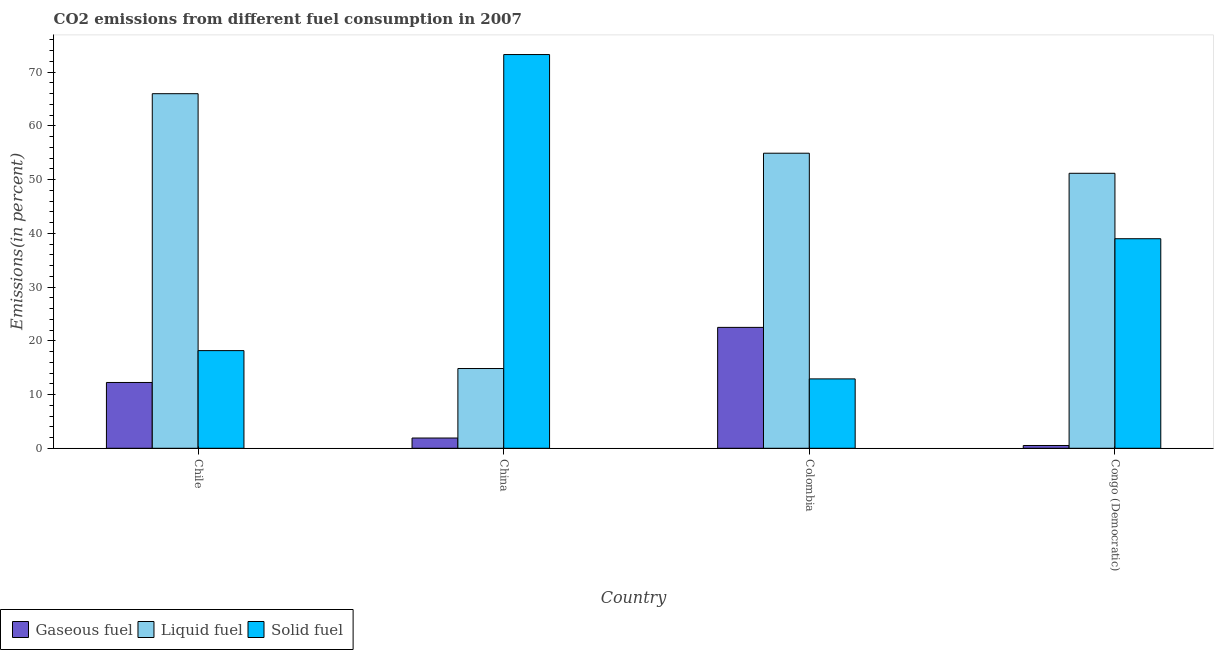How many different coloured bars are there?
Provide a short and direct response. 3. Are the number of bars per tick equal to the number of legend labels?
Your answer should be compact. Yes. Are the number of bars on each tick of the X-axis equal?
Make the answer very short. Yes. What is the percentage of solid fuel emission in Congo (Democratic)?
Make the answer very short. 38.99. Across all countries, what is the maximum percentage of liquid fuel emission?
Offer a very short reply. 65.98. Across all countries, what is the minimum percentage of solid fuel emission?
Your answer should be very brief. 12.91. In which country was the percentage of gaseous fuel emission maximum?
Keep it short and to the point. Colombia. In which country was the percentage of liquid fuel emission minimum?
Offer a very short reply. China. What is the total percentage of liquid fuel emission in the graph?
Provide a succinct answer. 186.88. What is the difference between the percentage of liquid fuel emission in Chile and that in Congo (Democratic)?
Your answer should be compact. 14.81. What is the difference between the percentage of liquid fuel emission in China and the percentage of gaseous fuel emission in Chile?
Your answer should be very brief. 2.6. What is the average percentage of solid fuel emission per country?
Offer a terse response. 35.83. What is the difference between the percentage of solid fuel emission and percentage of liquid fuel emission in Congo (Democratic)?
Provide a succinct answer. -12.18. In how many countries, is the percentage of liquid fuel emission greater than 60 %?
Make the answer very short. 1. What is the ratio of the percentage of gaseous fuel emission in Chile to that in China?
Your answer should be compact. 6.42. Is the percentage of solid fuel emission in Chile less than that in China?
Provide a succinct answer. Yes. What is the difference between the highest and the second highest percentage of liquid fuel emission?
Your answer should be very brief. 11.07. What is the difference between the highest and the lowest percentage of gaseous fuel emission?
Offer a terse response. 21.98. Is the sum of the percentage of gaseous fuel emission in China and Colombia greater than the maximum percentage of solid fuel emission across all countries?
Provide a short and direct response. No. What does the 3rd bar from the left in Colombia represents?
Provide a short and direct response. Solid fuel. What does the 3rd bar from the right in Colombia represents?
Your response must be concise. Gaseous fuel. How many bars are there?
Offer a terse response. 12. How many countries are there in the graph?
Offer a terse response. 4. Does the graph contain grids?
Make the answer very short. No. Where does the legend appear in the graph?
Ensure brevity in your answer.  Bottom left. How are the legend labels stacked?
Offer a terse response. Horizontal. What is the title of the graph?
Offer a terse response. CO2 emissions from different fuel consumption in 2007. What is the label or title of the X-axis?
Offer a very short reply. Country. What is the label or title of the Y-axis?
Give a very brief answer. Emissions(in percent). What is the Emissions(in percent) in Gaseous fuel in Chile?
Make the answer very short. 12.24. What is the Emissions(in percent) in Liquid fuel in Chile?
Offer a very short reply. 65.98. What is the Emissions(in percent) of Solid fuel in Chile?
Keep it short and to the point. 18.17. What is the Emissions(in percent) of Gaseous fuel in China?
Your response must be concise. 1.91. What is the Emissions(in percent) of Liquid fuel in China?
Your answer should be very brief. 14.84. What is the Emissions(in percent) of Solid fuel in China?
Offer a terse response. 73.26. What is the Emissions(in percent) in Gaseous fuel in Colombia?
Your answer should be compact. 22.5. What is the Emissions(in percent) in Liquid fuel in Colombia?
Your answer should be compact. 54.9. What is the Emissions(in percent) in Solid fuel in Colombia?
Keep it short and to the point. 12.91. What is the Emissions(in percent) of Gaseous fuel in Congo (Democratic)?
Your answer should be compact. 0.52. What is the Emissions(in percent) in Liquid fuel in Congo (Democratic)?
Your answer should be compact. 51.17. What is the Emissions(in percent) in Solid fuel in Congo (Democratic)?
Ensure brevity in your answer.  38.99. Across all countries, what is the maximum Emissions(in percent) of Gaseous fuel?
Provide a short and direct response. 22.5. Across all countries, what is the maximum Emissions(in percent) of Liquid fuel?
Ensure brevity in your answer.  65.98. Across all countries, what is the maximum Emissions(in percent) in Solid fuel?
Make the answer very short. 73.26. Across all countries, what is the minimum Emissions(in percent) in Gaseous fuel?
Ensure brevity in your answer.  0.52. Across all countries, what is the minimum Emissions(in percent) in Liquid fuel?
Make the answer very short. 14.84. Across all countries, what is the minimum Emissions(in percent) in Solid fuel?
Your response must be concise. 12.91. What is the total Emissions(in percent) in Gaseous fuel in the graph?
Keep it short and to the point. 37.17. What is the total Emissions(in percent) of Liquid fuel in the graph?
Keep it short and to the point. 186.88. What is the total Emissions(in percent) of Solid fuel in the graph?
Offer a terse response. 143.33. What is the difference between the Emissions(in percent) in Gaseous fuel in Chile and that in China?
Ensure brevity in your answer.  10.34. What is the difference between the Emissions(in percent) in Liquid fuel in Chile and that in China?
Offer a terse response. 51.14. What is the difference between the Emissions(in percent) in Solid fuel in Chile and that in China?
Your answer should be very brief. -55.09. What is the difference between the Emissions(in percent) of Gaseous fuel in Chile and that in Colombia?
Make the answer very short. -10.25. What is the difference between the Emissions(in percent) of Liquid fuel in Chile and that in Colombia?
Keep it short and to the point. 11.07. What is the difference between the Emissions(in percent) of Solid fuel in Chile and that in Colombia?
Offer a very short reply. 5.26. What is the difference between the Emissions(in percent) in Gaseous fuel in Chile and that in Congo (Democratic)?
Provide a succinct answer. 11.73. What is the difference between the Emissions(in percent) in Liquid fuel in Chile and that in Congo (Democratic)?
Provide a short and direct response. 14.81. What is the difference between the Emissions(in percent) in Solid fuel in Chile and that in Congo (Democratic)?
Your answer should be compact. -20.82. What is the difference between the Emissions(in percent) in Gaseous fuel in China and that in Colombia?
Offer a very short reply. -20.59. What is the difference between the Emissions(in percent) in Liquid fuel in China and that in Colombia?
Keep it short and to the point. -40.06. What is the difference between the Emissions(in percent) of Solid fuel in China and that in Colombia?
Your answer should be compact. 60.35. What is the difference between the Emissions(in percent) of Gaseous fuel in China and that in Congo (Democratic)?
Offer a very short reply. 1.39. What is the difference between the Emissions(in percent) in Liquid fuel in China and that in Congo (Democratic)?
Ensure brevity in your answer.  -36.33. What is the difference between the Emissions(in percent) in Solid fuel in China and that in Congo (Democratic)?
Your answer should be compact. 34.27. What is the difference between the Emissions(in percent) of Gaseous fuel in Colombia and that in Congo (Democratic)?
Give a very brief answer. 21.98. What is the difference between the Emissions(in percent) in Liquid fuel in Colombia and that in Congo (Democratic)?
Offer a very short reply. 3.74. What is the difference between the Emissions(in percent) of Solid fuel in Colombia and that in Congo (Democratic)?
Your response must be concise. -26.08. What is the difference between the Emissions(in percent) in Gaseous fuel in Chile and the Emissions(in percent) in Liquid fuel in China?
Offer a terse response. -2.6. What is the difference between the Emissions(in percent) of Gaseous fuel in Chile and the Emissions(in percent) of Solid fuel in China?
Ensure brevity in your answer.  -61.01. What is the difference between the Emissions(in percent) of Liquid fuel in Chile and the Emissions(in percent) of Solid fuel in China?
Ensure brevity in your answer.  -7.28. What is the difference between the Emissions(in percent) in Gaseous fuel in Chile and the Emissions(in percent) in Liquid fuel in Colombia?
Give a very brief answer. -42.66. What is the difference between the Emissions(in percent) in Gaseous fuel in Chile and the Emissions(in percent) in Solid fuel in Colombia?
Your answer should be compact. -0.67. What is the difference between the Emissions(in percent) in Liquid fuel in Chile and the Emissions(in percent) in Solid fuel in Colombia?
Provide a short and direct response. 53.07. What is the difference between the Emissions(in percent) of Gaseous fuel in Chile and the Emissions(in percent) of Liquid fuel in Congo (Democratic)?
Ensure brevity in your answer.  -38.92. What is the difference between the Emissions(in percent) of Gaseous fuel in Chile and the Emissions(in percent) of Solid fuel in Congo (Democratic)?
Your response must be concise. -26.75. What is the difference between the Emissions(in percent) in Liquid fuel in Chile and the Emissions(in percent) in Solid fuel in Congo (Democratic)?
Provide a short and direct response. 26.99. What is the difference between the Emissions(in percent) of Gaseous fuel in China and the Emissions(in percent) of Liquid fuel in Colombia?
Provide a succinct answer. -52.99. What is the difference between the Emissions(in percent) of Gaseous fuel in China and the Emissions(in percent) of Solid fuel in Colombia?
Offer a very short reply. -11. What is the difference between the Emissions(in percent) in Liquid fuel in China and the Emissions(in percent) in Solid fuel in Colombia?
Your answer should be compact. 1.93. What is the difference between the Emissions(in percent) of Gaseous fuel in China and the Emissions(in percent) of Liquid fuel in Congo (Democratic)?
Provide a succinct answer. -49.26. What is the difference between the Emissions(in percent) in Gaseous fuel in China and the Emissions(in percent) in Solid fuel in Congo (Democratic)?
Offer a very short reply. -37.08. What is the difference between the Emissions(in percent) of Liquid fuel in China and the Emissions(in percent) of Solid fuel in Congo (Democratic)?
Provide a short and direct response. -24.15. What is the difference between the Emissions(in percent) in Gaseous fuel in Colombia and the Emissions(in percent) in Liquid fuel in Congo (Democratic)?
Offer a terse response. -28.67. What is the difference between the Emissions(in percent) in Gaseous fuel in Colombia and the Emissions(in percent) in Solid fuel in Congo (Democratic)?
Offer a very short reply. -16.49. What is the difference between the Emissions(in percent) of Liquid fuel in Colombia and the Emissions(in percent) of Solid fuel in Congo (Democratic)?
Make the answer very short. 15.91. What is the average Emissions(in percent) in Gaseous fuel per country?
Give a very brief answer. 9.29. What is the average Emissions(in percent) of Liquid fuel per country?
Provide a short and direct response. 46.72. What is the average Emissions(in percent) of Solid fuel per country?
Offer a very short reply. 35.83. What is the difference between the Emissions(in percent) of Gaseous fuel and Emissions(in percent) of Liquid fuel in Chile?
Offer a very short reply. -53.73. What is the difference between the Emissions(in percent) in Gaseous fuel and Emissions(in percent) in Solid fuel in Chile?
Offer a terse response. -5.93. What is the difference between the Emissions(in percent) of Liquid fuel and Emissions(in percent) of Solid fuel in Chile?
Your answer should be very brief. 47.8. What is the difference between the Emissions(in percent) of Gaseous fuel and Emissions(in percent) of Liquid fuel in China?
Provide a short and direct response. -12.93. What is the difference between the Emissions(in percent) in Gaseous fuel and Emissions(in percent) in Solid fuel in China?
Give a very brief answer. -71.35. What is the difference between the Emissions(in percent) in Liquid fuel and Emissions(in percent) in Solid fuel in China?
Your answer should be very brief. -58.42. What is the difference between the Emissions(in percent) of Gaseous fuel and Emissions(in percent) of Liquid fuel in Colombia?
Offer a terse response. -32.41. What is the difference between the Emissions(in percent) in Gaseous fuel and Emissions(in percent) in Solid fuel in Colombia?
Your answer should be compact. 9.59. What is the difference between the Emissions(in percent) in Liquid fuel and Emissions(in percent) in Solid fuel in Colombia?
Provide a short and direct response. 41.99. What is the difference between the Emissions(in percent) in Gaseous fuel and Emissions(in percent) in Liquid fuel in Congo (Democratic)?
Make the answer very short. -50.65. What is the difference between the Emissions(in percent) of Gaseous fuel and Emissions(in percent) of Solid fuel in Congo (Democratic)?
Provide a succinct answer. -38.47. What is the difference between the Emissions(in percent) of Liquid fuel and Emissions(in percent) of Solid fuel in Congo (Democratic)?
Your answer should be compact. 12.18. What is the ratio of the Emissions(in percent) of Gaseous fuel in Chile to that in China?
Offer a terse response. 6.42. What is the ratio of the Emissions(in percent) of Liquid fuel in Chile to that in China?
Your answer should be very brief. 4.45. What is the ratio of the Emissions(in percent) of Solid fuel in Chile to that in China?
Your response must be concise. 0.25. What is the ratio of the Emissions(in percent) in Gaseous fuel in Chile to that in Colombia?
Your response must be concise. 0.54. What is the ratio of the Emissions(in percent) of Liquid fuel in Chile to that in Colombia?
Ensure brevity in your answer.  1.2. What is the ratio of the Emissions(in percent) of Solid fuel in Chile to that in Colombia?
Provide a short and direct response. 1.41. What is the ratio of the Emissions(in percent) of Gaseous fuel in Chile to that in Congo (Democratic)?
Make the answer very short. 23.63. What is the ratio of the Emissions(in percent) of Liquid fuel in Chile to that in Congo (Democratic)?
Provide a short and direct response. 1.29. What is the ratio of the Emissions(in percent) in Solid fuel in Chile to that in Congo (Democratic)?
Ensure brevity in your answer.  0.47. What is the ratio of the Emissions(in percent) of Gaseous fuel in China to that in Colombia?
Your answer should be compact. 0.08. What is the ratio of the Emissions(in percent) in Liquid fuel in China to that in Colombia?
Make the answer very short. 0.27. What is the ratio of the Emissions(in percent) in Solid fuel in China to that in Colombia?
Keep it short and to the point. 5.67. What is the ratio of the Emissions(in percent) of Gaseous fuel in China to that in Congo (Democratic)?
Offer a terse response. 3.68. What is the ratio of the Emissions(in percent) in Liquid fuel in China to that in Congo (Democratic)?
Ensure brevity in your answer.  0.29. What is the ratio of the Emissions(in percent) of Solid fuel in China to that in Congo (Democratic)?
Offer a very short reply. 1.88. What is the ratio of the Emissions(in percent) of Gaseous fuel in Colombia to that in Congo (Democratic)?
Provide a short and direct response. 43.42. What is the ratio of the Emissions(in percent) of Liquid fuel in Colombia to that in Congo (Democratic)?
Provide a succinct answer. 1.07. What is the ratio of the Emissions(in percent) in Solid fuel in Colombia to that in Congo (Democratic)?
Give a very brief answer. 0.33. What is the difference between the highest and the second highest Emissions(in percent) in Gaseous fuel?
Ensure brevity in your answer.  10.25. What is the difference between the highest and the second highest Emissions(in percent) in Liquid fuel?
Keep it short and to the point. 11.07. What is the difference between the highest and the second highest Emissions(in percent) of Solid fuel?
Provide a short and direct response. 34.27. What is the difference between the highest and the lowest Emissions(in percent) in Gaseous fuel?
Make the answer very short. 21.98. What is the difference between the highest and the lowest Emissions(in percent) of Liquid fuel?
Provide a short and direct response. 51.14. What is the difference between the highest and the lowest Emissions(in percent) of Solid fuel?
Offer a terse response. 60.35. 